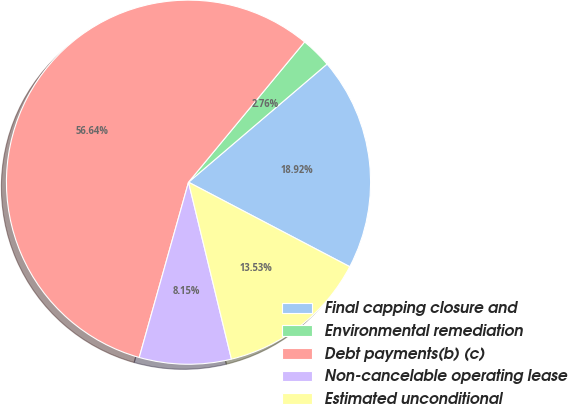Convert chart. <chart><loc_0><loc_0><loc_500><loc_500><pie_chart><fcel>Final capping closure and<fcel>Environmental remediation<fcel>Debt payments(b) (c)<fcel>Non-cancelable operating lease<fcel>Estimated unconditional<nl><fcel>18.92%<fcel>2.76%<fcel>56.64%<fcel>8.15%<fcel>13.53%<nl></chart> 